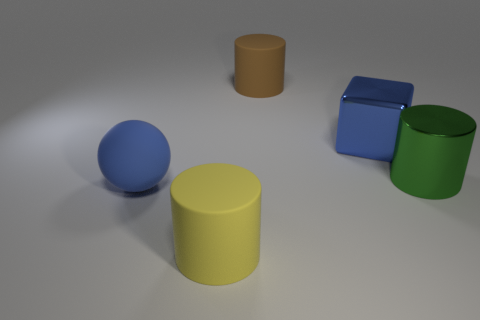There is a large cylinder that is behind the object that is on the right side of the big shiny block; are there any large objects in front of it?
Your response must be concise. Yes. There is a yellow object that is the same shape as the large green metallic object; what material is it?
Offer a terse response. Rubber. How many balls are large cyan objects or brown objects?
Provide a succinct answer. 0. The blue object to the left of the metallic thing that is to the left of the large metal cylinder is made of what material?
Offer a very short reply. Rubber. Are there fewer metal cubes that are on the left side of the brown rubber cylinder than big metallic objects?
Offer a very short reply. Yes. There is a yellow thing that is made of the same material as the blue ball; what is its shape?
Offer a terse response. Cylinder. How many other things are there of the same shape as the big brown matte thing?
Your response must be concise. 2. What number of brown objects are either shiny cylinders or rubber cubes?
Offer a very short reply. 0. Is the shape of the yellow matte thing the same as the blue matte object?
Your answer should be very brief. No. Are there any blue things behind the large blue object right of the large brown matte cylinder?
Provide a succinct answer. No. 